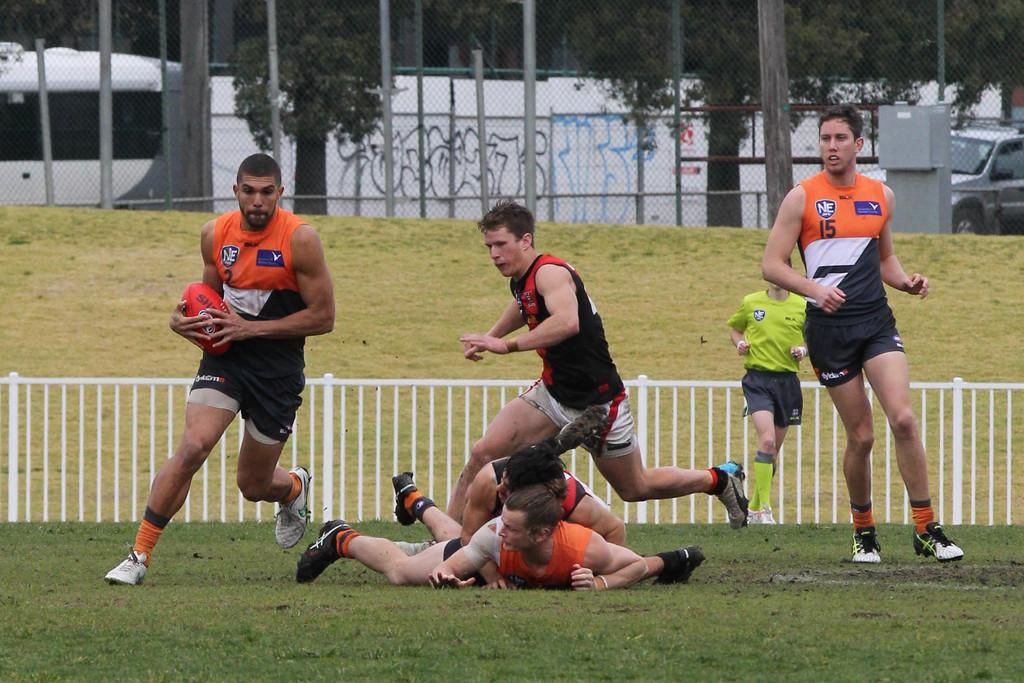<image>
Summarize the visual content of the image. One of the rugby players has the number 15 on his shirt 